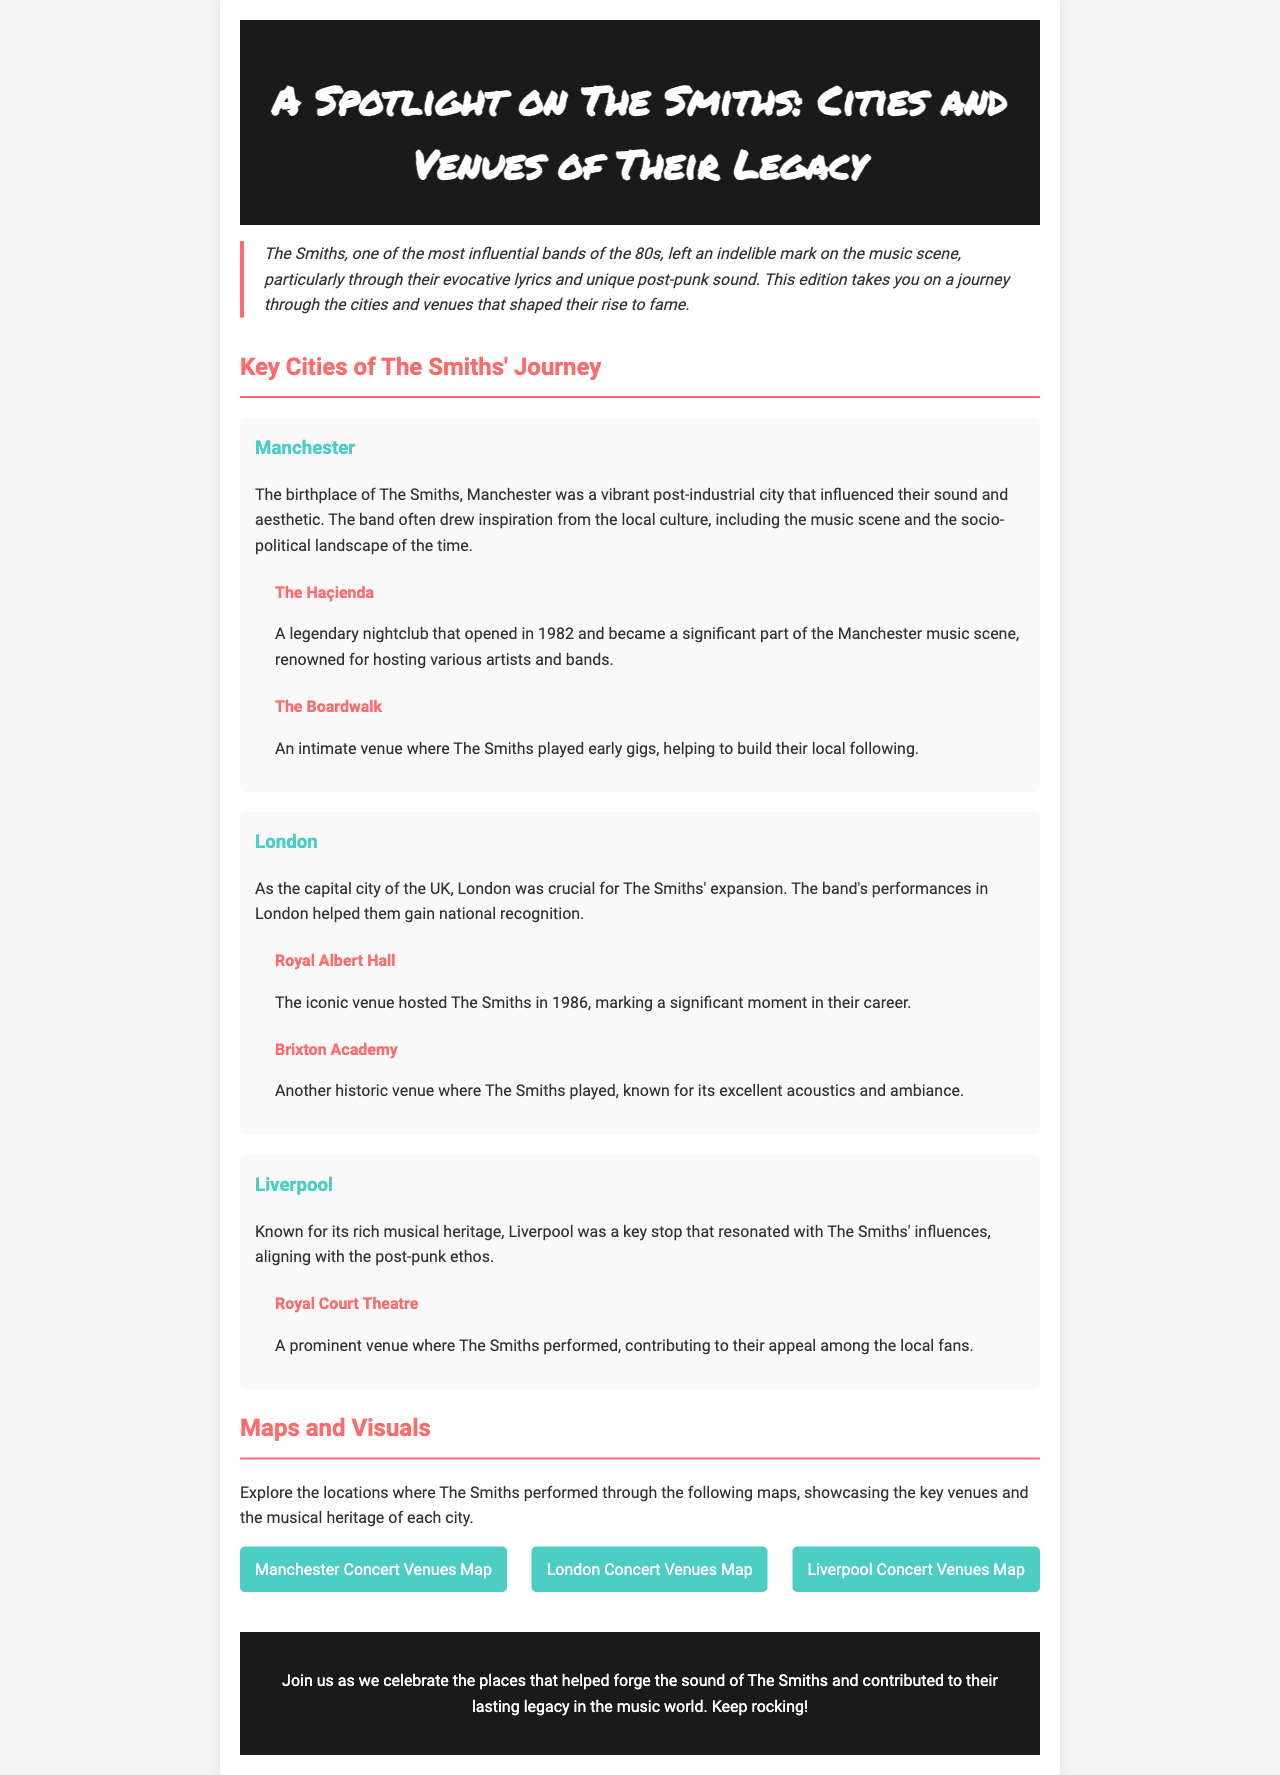What city is known as the birthplace of The Smiths? The document states that Manchester is the birthplace of The Smiths, highlighting its vibrant cultural influence on the band.
Answer: Manchester Which venue is associated with The Smiths' significant performance in London? The Royal Albert Hall is specifically mentioned as a key venue where The Smiths performed, marking a pivotal moment in their career.
Answer: Royal Albert Hall How many venues are listed for Manchester? The document lists two venues in Manchester where The Smiths played, reflecting the city's importance to their early journey.
Answer: 2 What year did The Haçienda open? While the exact year is not explicitly stated for The Haçienda, it is noted that it opened in 1982, providing context for its association with The Smiths.
Answer: 1982 Which city hosted The Smiths during their rise to fame? The document cites London as a crucial city for The Smiths' expansion and gaining national recognition through their performances.
Answer: London Which venue did The Smiths perform at in Liverpool? The Royal Court Theatre is identified as the prominent venue in Liverpool where The Smiths performed, showcasing their appeal among local fans.
Answer: Royal Court Theatre What color scheme is used for the headings in the document? The headings in the document are highlighted in a specific color scheme primarily featuring shades like #ff6b6b for major sections and #4ecdc4 for city names.
Answer: Red and teal How many maps are provided for the concert venues? The document mentions three maps to explore concert venues in different cities associated with The Smiths' performances.
Answer: 3 